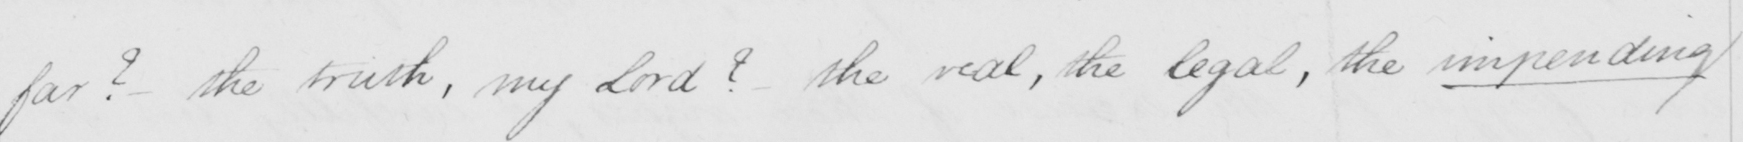Transcribe the text shown in this historical manuscript line. far ?   _  the truth , my Lord ?   _  the real , the legal  , the impending 